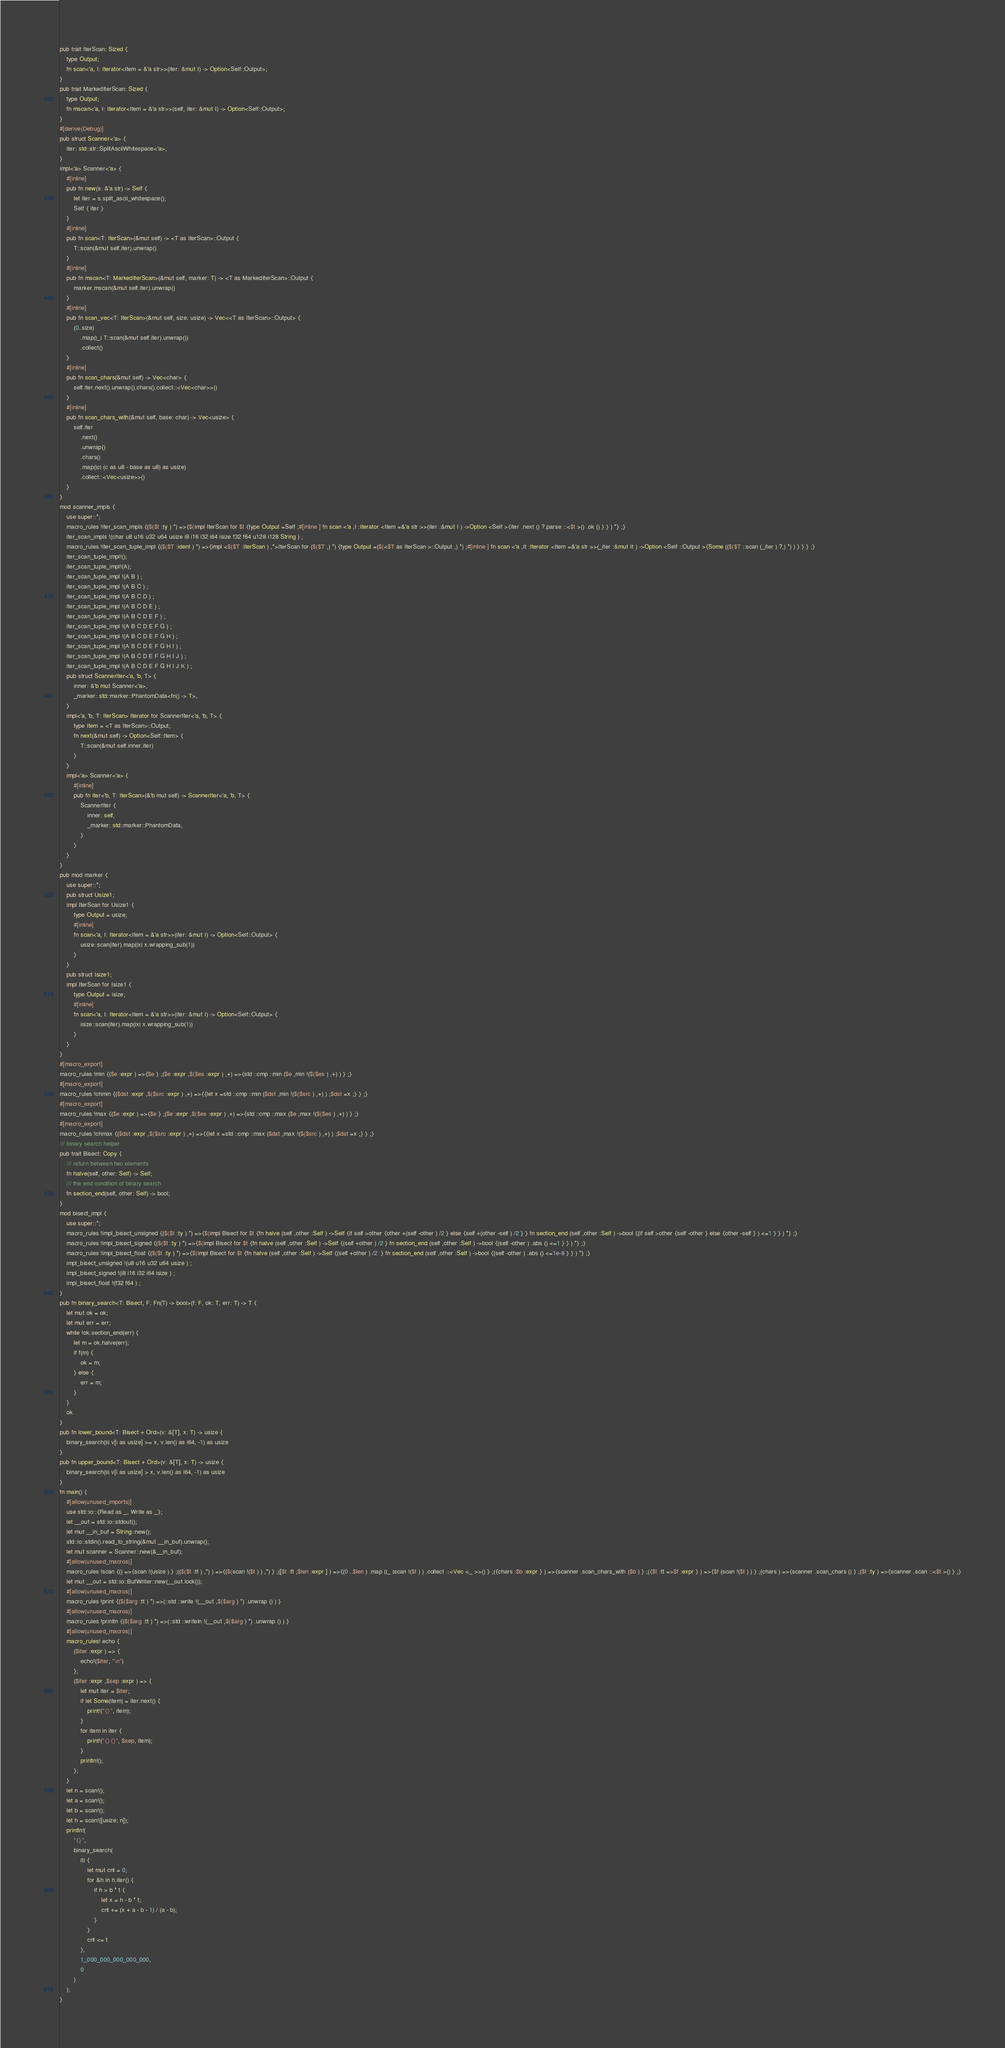<code> <loc_0><loc_0><loc_500><loc_500><_Rust_>pub trait IterScan: Sized {
    type Output;
    fn scan<'a, I: Iterator<Item = &'a str>>(iter: &mut I) -> Option<Self::Output>;
}
pub trait MarkedIterScan: Sized {
    type Output;
    fn mscan<'a, I: Iterator<Item = &'a str>>(self, iter: &mut I) -> Option<Self::Output>;
}
#[derive(Debug)]
pub struct Scanner<'a> {
    iter: std::str::SplitAsciiWhitespace<'a>,
}
impl<'a> Scanner<'a> {
    #[inline]
    pub fn new(s: &'a str) -> Self {
        let iter = s.split_ascii_whitespace();
        Self { iter }
    }
    #[inline]
    pub fn scan<T: IterScan>(&mut self) -> <T as IterScan>::Output {
        T::scan(&mut self.iter).unwrap()
    }
    #[inline]
    pub fn mscan<T: MarkedIterScan>(&mut self, marker: T) -> <T as MarkedIterScan>::Output {
        marker.mscan(&mut self.iter).unwrap()
    }
    #[inline]
    pub fn scan_vec<T: IterScan>(&mut self, size: usize) -> Vec<<T as IterScan>::Output> {
        (0..size)
            .map(|_| T::scan(&mut self.iter).unwrap())
            .collect()
    }
    #[inline]
    pub fn scan_chars(&mut self) -> Vec<char> {
        self.iter.next().unwrap().chars().collect::<Vec<char>>()
    }
    #[inline]
    pub fn scan_chars_with(&mut self, base: char) -> Vec<usize> {
        self.iter
            .next()
            .unwrap()
            .chars()
            .map(|c| (c as u8 - base as u8) as usize)
            .collect::<Vec<usize>>()
    }
}
mod scanner_impls {
    use super::*;
    macro_rules !iter_scan_impls {($($t :ty ) *) =>{$(impl IterScan for $t {type Output =Self ;#[inline ] fn scan <'a ,I :Iterator <Item =&'a str >>(iter :&mut I ) ->Option <Self >{iter .next () ?.parse ::<$t >() .ok () } } ) *} ;}
    iter_scan_impls !(char u8 u16 u32 u64 usize i8 i16 i32 i64 isize f32 f64 u128 i128 String ) ;
    macro_rules !iter_scan_tuple_impl {($($T :ident ) *) =>{impl <$($T :IterScan ) ,*>IterScan for ($($T ,) *) {type Output =($(<$T as IterScan >::Output ,) *) ;#[inline ] fn scan <'a ,It :Iterator <Item =&'a str >>(_iter :&mut It ) ->Option <Self ::Output >{Some (($($T ::scan (_iter ) ?,) *) ) } } } ;}
    iter_scan_tuple_impl!();
    iter_scan_tuple_impl!(A);
    iter_scan_tuple_impl !(A B ) ;
    iter_scan_tuple_impl !(A B C ) ;
    iter_scan_tuple_impl !(A B C D ) ;
    iter_scan_tuple_impl !(A B C D E ) ;
    iter_scan_tuple_impl !(A B C D E F ) ;
    iter_scan_tuple_impl !(A B C D E F G ) ;
    iter_scan_tuple_impl !(A B C D E F G H ) ;
    iter_scan_tuple_impl !(A B C D E F G H I ) ;
    iter_scan_tuple_impl !(A B C D E F G H I J ) ;
    iter_scan_tuple_impl !(A B C D E F G H I J K ) ;
    pub struct ScannerIter<'a, 'b, T> {
        inner: &'b mut Scanner<'a>,
        _marker: std::marker::PhantomData<fn() -> T>,
    }
    impl<'a, 'b, T: IterScan> Iterator for ScannerIter<'a, 'b, T> {
        type Item = <T as IterScan>::Output;
        fn next(&mut self) -> Option<Self::Item> {
            T::scan(&mut self.inner.iter)
        }
    }
    impl<'a> Scanner<'a> {
        #[inline]
        pub fn iter<'b, T: IterScan>(&'b mut self) -> ScannerIter<'a, 'b, T> {
            ScannerIter {
                inner: self,
                _marker: std::marker::PhantomData,
            }
        }
    }
}
pub mod marker {
    use super::*;
    pub struct Usize1;
    impl IterScan for Usize1 {
        type Output = usize;
        #[inline]
        fn scan<'a, I: Iterator<Item = &'a str>>(iter: &mut I) -> Option<Self::Output> {
            usize::scan(iter).map(|x| x.wrapping_sub(1))
        }
    }
    pub struct Isize1;
    impl IterScan for Isize1 {
        type Output = isize;
        #[inline]
        fn scan<'a, I: Iterator<Item = &'a str>>(iter: &mut I) -> Option<Self::Output> {
            isize::scan(iter).map(|x| x.wrapping_sub(1))
        }
    }
}
#[macro_export]
macro_rules !min {($e :expr ) =>{$e } ;($e :expr ,$($es :expr ) ,+) =>{std ::cmp ::min ($e ,min !($($es ) ,+) ) } ;}
#[macro_export]
macro_rules !chmin {($dst :expr ,$($src :expr ) ,+) =>{{let x =std ::cmp ::min ($dst ,min !($($src ) ,+) ) ;$dst =x ;} } ;}
#[macro_export]
macro_rules !max {($e :expr ) =>{$e } ;($e :expr ,$($es :expr ) ,+) =>{std ::cmp ::max ($e ,max !($($es ) ,+) ) } ;}
#[macro_export]
macro_rules !chmax {($dst :expr ,$($src :expr ) ,+) =>{{let x =std ::cmp ::max ($dst ,max !($($src ) ,+) ) ;$dst =x ;} } ;}
/// binary search helper
pub trait Bisect: Copy {
    /// return between two elements
    fn halve(self, other: Self) -> Self;
    /// the end condition of binary search
    fn section_end(self, other: Self) -> bool;
}
mod bisect_impl {
    use super::*;
    macro_rules !impl_bisect_unsigned {($($t :ty ) *) =>{$(impl Bisect for $t {fn halve (self ,other :Self ) ->Self {if self >other {other +(self -other ) /2 } else {self +(other -self ) /2 } } fn section_end (self ,other :Self ) ->bool {(if self >other {self -other } else {other -self } ) <=1 } } ) *} ;}
    macro_rules !impl_bisect_signed {($($t :ty ) *) =>{$(impl Bisect for $t {fn halve (self ,other :Self ) ->Self {(self +other ) /2 } fn section_end (self ,other :Self ) ->bool {(self -other ) .abs () <=1 } } ) *} ;}
    macro_rules !impl_bisect_float {($($t :ty ) *) =>{$(impl Bisect for $t {fn halve (self ,other :Self ) ->Self {(self +other ) /2. } fn section_end (self ,other :Self ) ->bool {(self -other ) .abs () <=1e-8 } } ) *} ;}
    impl_bisect_unsigned !(u8 u16 u32 u64 usize ) ;
    impl_bisect_signed !(i8 i16 i32 i64 isize ) ;
    impl_bisect_float !(f32 f64 ) ;
}
pub fn binary_search<T: Bisect, F: Fn(T) -> bool>(f: F, ok: T, err: T) -> T {
    let mut ok = ok;
    let mut err = err;
    while !ok.section_end(err) {
        let m = ok.halve(err);
        if f(m) {
            ok = m;
        } else {
            err = m;
        }
    }
    ok
}
pub fn lower_bound<T: Bisect + Ord>(v: &[T], x: T) -> usize {
    binary_search(|i| v[i as usize] >= x, v.len() as i64, -1) as usize
}
pub fn upper_bound<T: Bisect + Ord>(v: &[T], x: T) -> usize {
    binary_search(|i| v[i as usize] > x, v.len() as i64, -1) as usize
}
fn main() {
    #[allow(unused_imports)]
    use std::io::{Read as _, Write as _};
    let __out = std::io::stdout();
    let mut __in_buf = String::new();
    std::io::stdin().read_to_string(&mut __in_buf).unwrap();
    let mut scanner = Scanner::new(&__in_buf);
    #[allow(unused_macros)]
    macro_rules !scan {() =>{scan !(usize ) } ;(($($t :tt ) ,*) ) =>{($(scan !($t ) ) ,*) } ;([$t :tt ;$len :expr ] ) =>{(0 ..$len ) .map (|_ |scan !($t ) ) .collect ::<Vec <_ >>() } ;({chars :$b :expr } ) =>{scanner .scan_chars_with ($b ) } ;({$t :tt =>$f :expr } ) =>{$f (scan !($t ) ) } ;(chars ) =>{scanner .scan_chars () } ;($t :ty ) =>{scanner .scan ::<$t >() } ;}
    let mut __out = std::io::BufWriter::new(__out.lock());
    #[allow(unused_macros)]
    macro_rules !print {($($arg :tt ) *) =>(::std ::write !(__out ,$($arg ) *) .unwrap () ) }
    #[allow(unused_macros)]
    macro_rules !println {($($arg :tt ) *) =>(::std ::writeln !(__out ,$($arg ) *) .unwrap () ) }
    #[allow(unused_macros)]
    macro_rules! echo {
        ($iter :expr ) => {
            echo!($iter, "\n")
        };
        ($iter :expr ,$sep :expr ) => {
            let mut iter = $iter;
            if let Some(item) = iter.next() {
                print!("{}", item);
            }
            for item in iter {
                print!("{}{}", $sep, item);
            }
            println!();
        };
    }
    let n = scan!();
    let a = scan!();
    let b = scan!();
    let h = scan!([usize; n]);
    println!(
        "{}",
        binary_search(
            |t| {
                let mut cnt = 0;
                for &h in h.iter() {
                    if h > b * t {
                        let x = h - b * t;
                        cnt += (x + a - b - 1) / (a - b);
                    }
                }
                cnt <= t
            },
            1_000_000_000_000_000,
            0
        )
    );
}</code> 